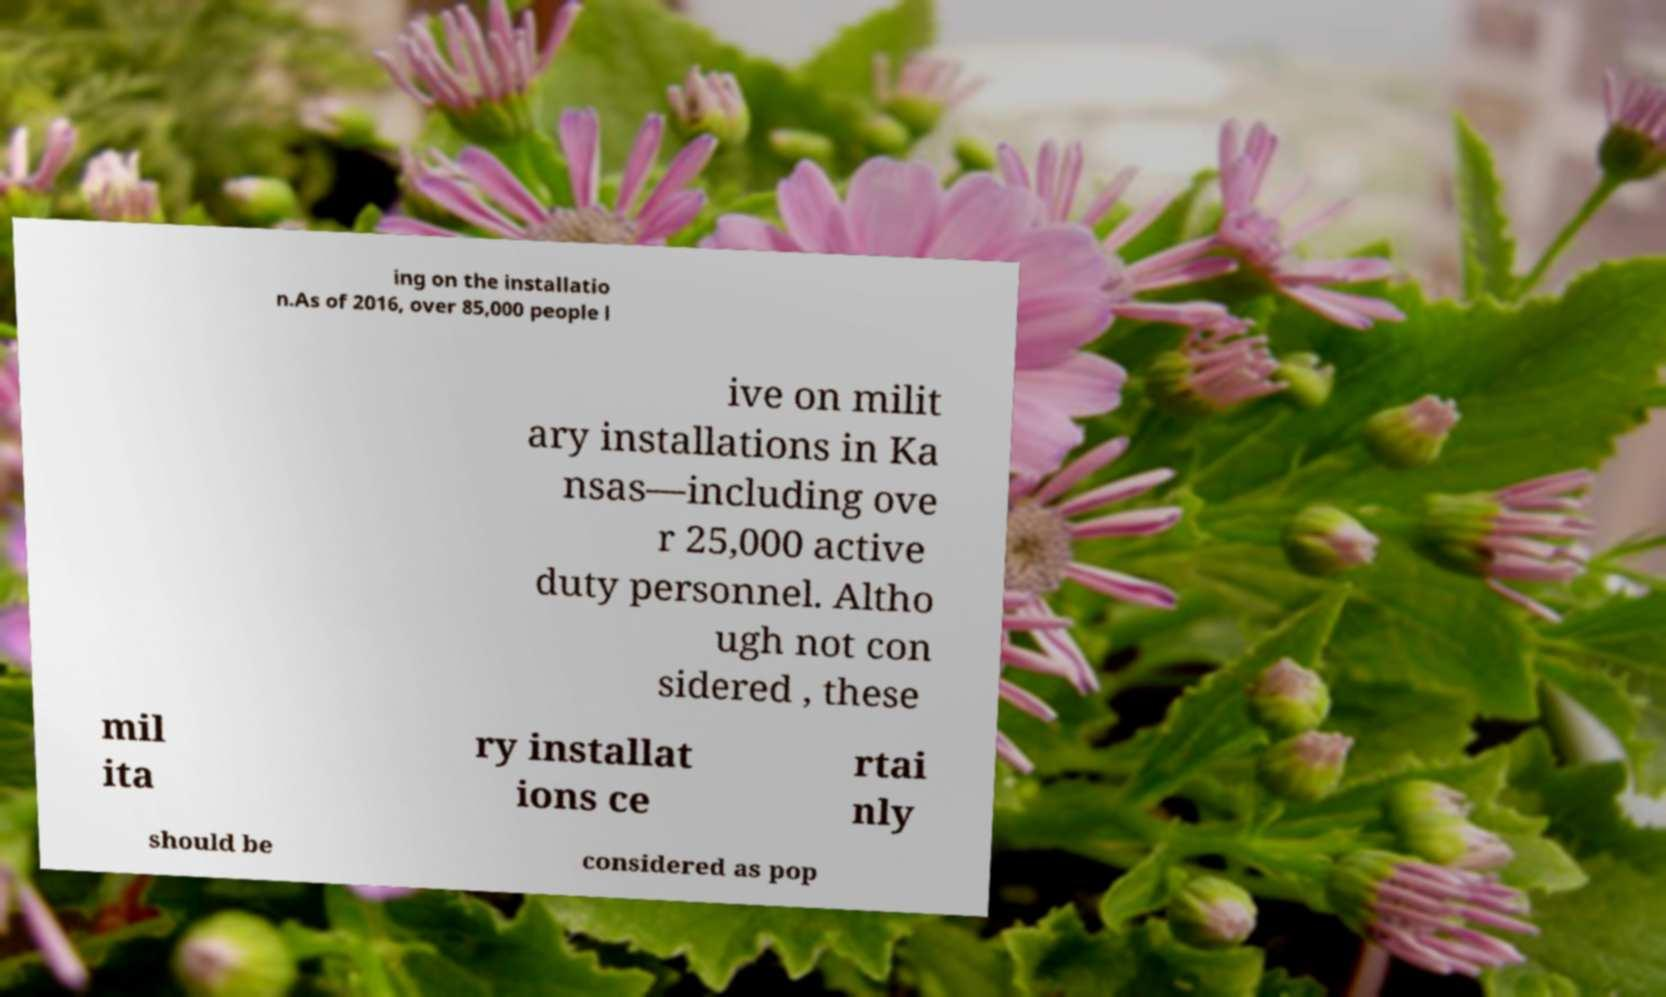Can you accurately transcribe the text from the provided image for me? ing on the installatio n.As of 2016, over 85,000 people l ive on milit ary installations in Ka nsas—including ove r 25,000 active duty personnel. Altho ugh not con sidered , these mil ita ry installat ions ce rtai nly should be considered as pop 